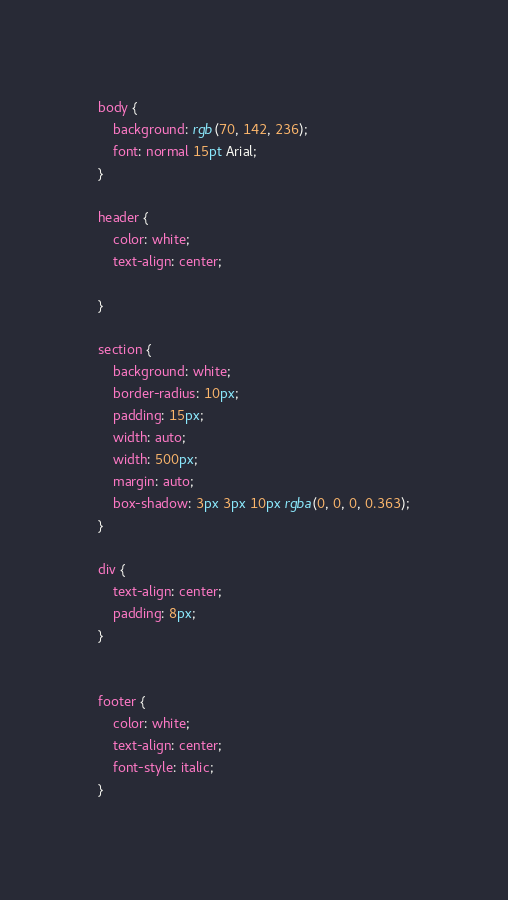Convert code to text. <code><loc_0><loc_0><loc_500><loc_500><_CSS_>body {
    background: rgb(70, 142, 236);
    font: normal 15pt Arial;
}

header {
    color: white;
    text-align: center;
    
}

section {
    background: white;
    border-radius: 10px;
    padding: 15px;
    width: auto;
    width: 500px;
    margin: auto;
    box-shadow: 3px 3px 10px rgba(0, 0, 0, 0.363);
}

div {
    text-align: center;
    padding: 8px;
}


footer {
    color: white;
    text-align: center;
    font-style: italic;
}</code> 